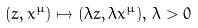<formula> <loc_0><loc_0><loc_500><loc_500>( z , x ^ { \mu } ) \mapsto ( \lambda z , \lambda x ^ { \mu } ) , \, \lambda > 0</formula> 